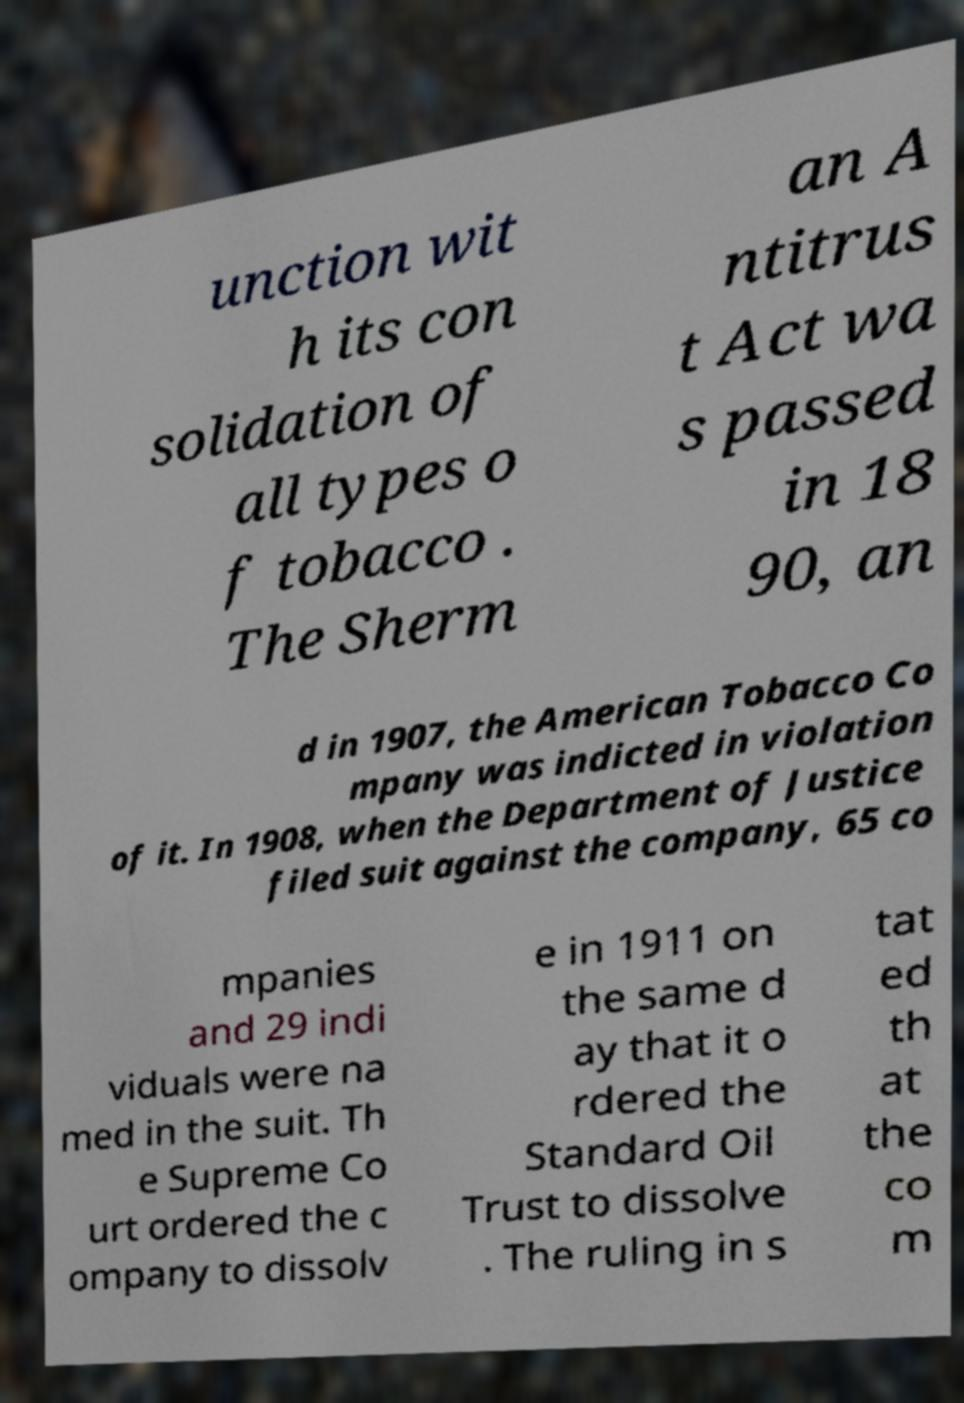For documentation purposes, I need the text within this image transcribed. Could you provide that? unction wit h its con solidation of all types o f tobacco . The Sherm an A ntitrus t Act wa s passed in 18 90, an d in 1907, the American Tobacco Co mpany was indicted in violation of it. In 1908, when the Department of Justice filed suit against the company, 65 co mpanies and 29 indi viduals were na med in the suit. Th e Supreme Co urt ordered the c ompany to dissolv e in 1911 on the same d ay that it o rdered the Standard Oil Trust to dissolve . The ruling in s tat ed th at the co m 